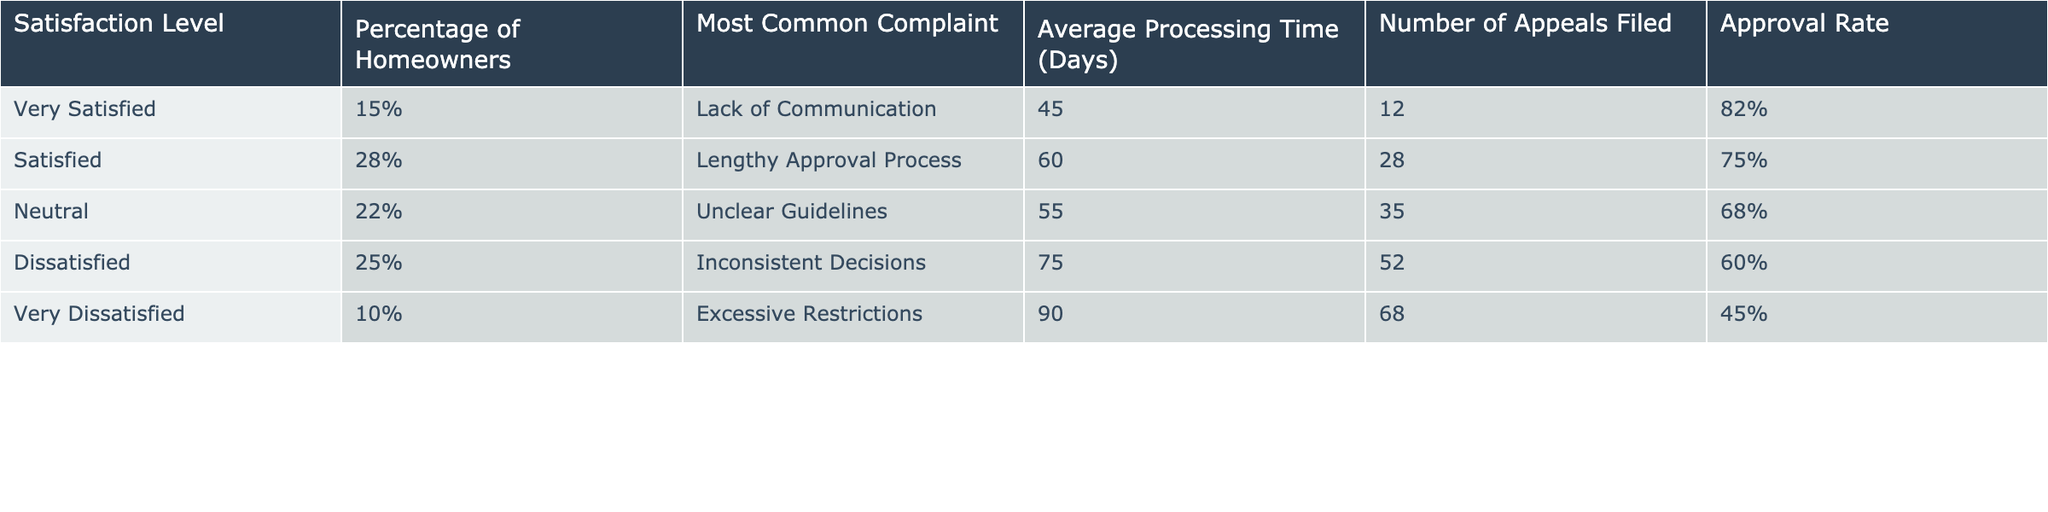What is the approval rate for dissatisfied homeowners? The approval rate for dissatisfied homeowners can be found in the table under the column "Approval Rate" corresponding to the row for "Dissatisfied," which states 60%.
Answer: 60% Which satisfaction level has the highest percentage of homeowners? By examining the "Percentage of Homeowners" column, "Satisfied" has the highest percentage at 28%.
Answer: 28% How many days does it take on average to process applications for very satisfied homeowners? The average processing time for very satisfied homeowners is listed under the "Average Processing Time (Days)" column for that satisfaction level, which is 45 days.
Answer: 45 days What is the difference in approval rate between very satisfied and very dissatisfied homeowners? The approval rate for very satisfied homeowners is 82% and for very dissatisfied homeowners is 45%. The difference is calculated as 82% - 45% = 37%.
Answer: 37% Is there a greater percentage of homeowners dissatisfied or very dissatisfied? The table shows that 25% of homeowners are dissatisfied, while 10% are very dissatisfied, thus there is a greater percentage of dissatisfied homeowners.
Answer: Yes What is the average processing time for homeowners who are neutral in their satisfaction? The average processing time is listed under the "Average Processing Time (Days)" for "Neutral," which is 55 days.
Answer: 55 days Which complaint is most commonly reported by satisfied homeowners? Checking the "Most Common Complaint" column, the complaint for satisfied homeowners is "Lengthy Approval Process."
Answer: Lengthy Approval Process If a homeowner is dissatisfied, how long do they typically wait for their application to be processed? The average processing time for dissatisfied homeowners is given in the table as 75 days.
Answer: 75 days What is the sum of the number of appeals filed by homeowners who are neutral and very dissatisfied? The number of appeals filed for neutral homeowners is 35 and for very dissatisfied homeowners is 68. Adding these together gives 35 + 68 = 103.
Answer: 103 Are homeowners overall more satisfied or dissatisfied with the city planning processes? The satisfaction levels show that the total percentage of satisfied and very satisfied homeowners (15% + 28% = 43%) is less than the total percentage of dissatisfied and very dissatisfied homeowners (25% + 10% = 35%). Therefore, they are more dissatisfied overall.
Answer: Dissatisfied 